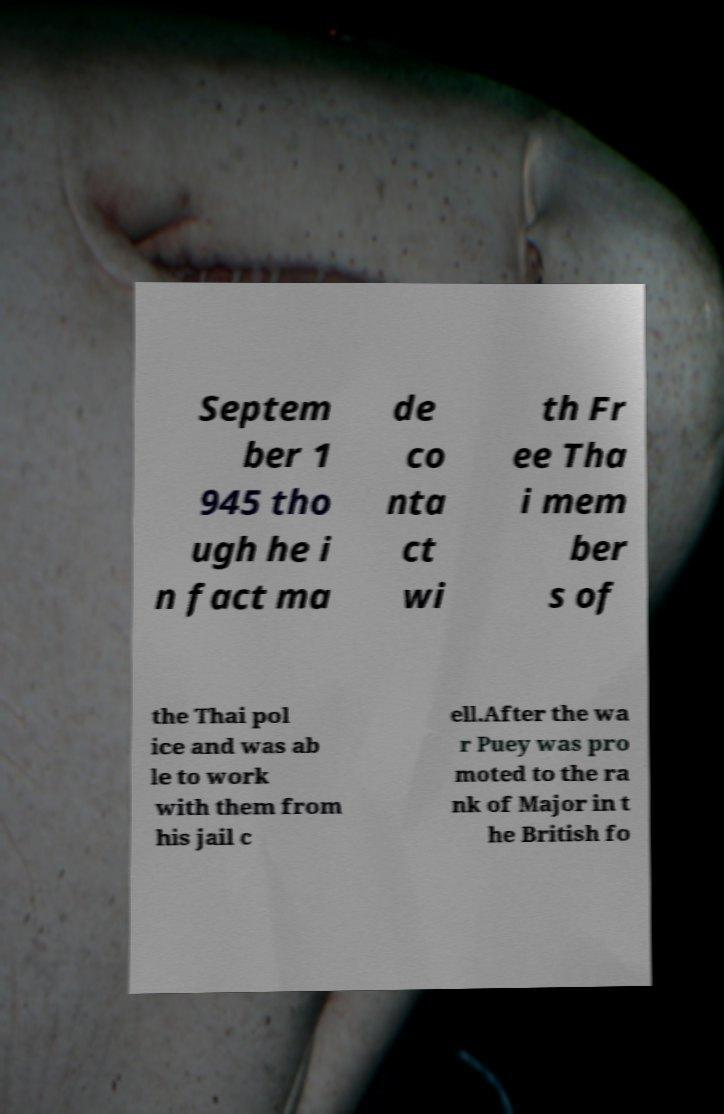Please read and relay the text visible in this image. What does it say? Septem ber 1 945 tho ugh he i n fact ma de co nta ct wi th Fr ee Tha i mem ber s of the Thai pol ice and was ab le to work with them from his jail c ell.After the wa r Puey was pro moted to the ra nk of Major in t he British fo 